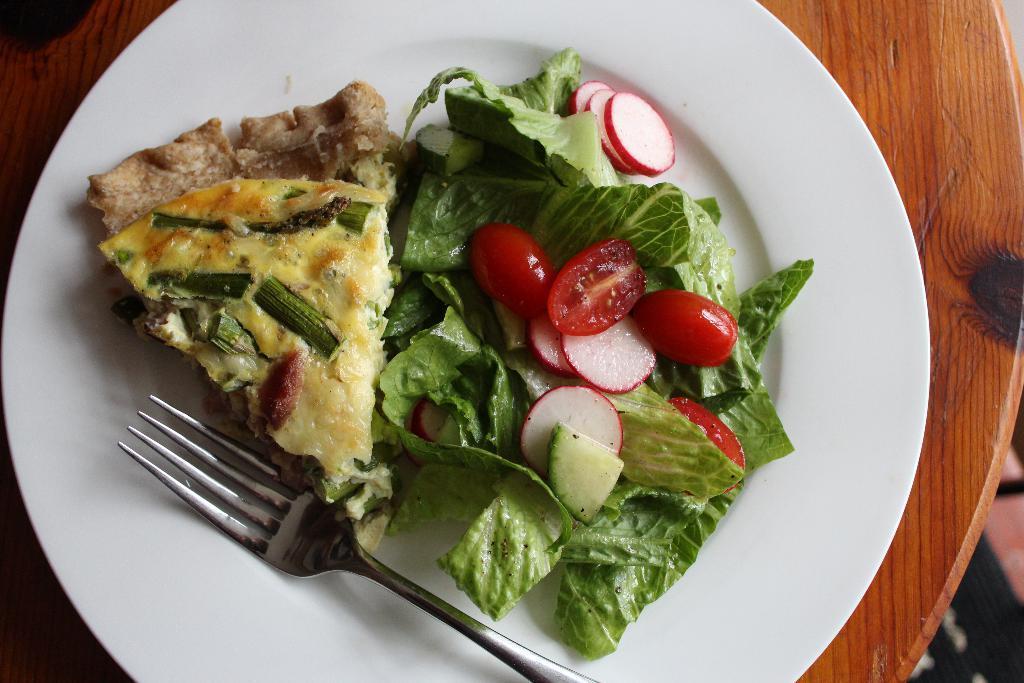Could you give a brief overview of what you see in this image? This image consists of food which is on the plate in the center and there is a folk on the plate. 